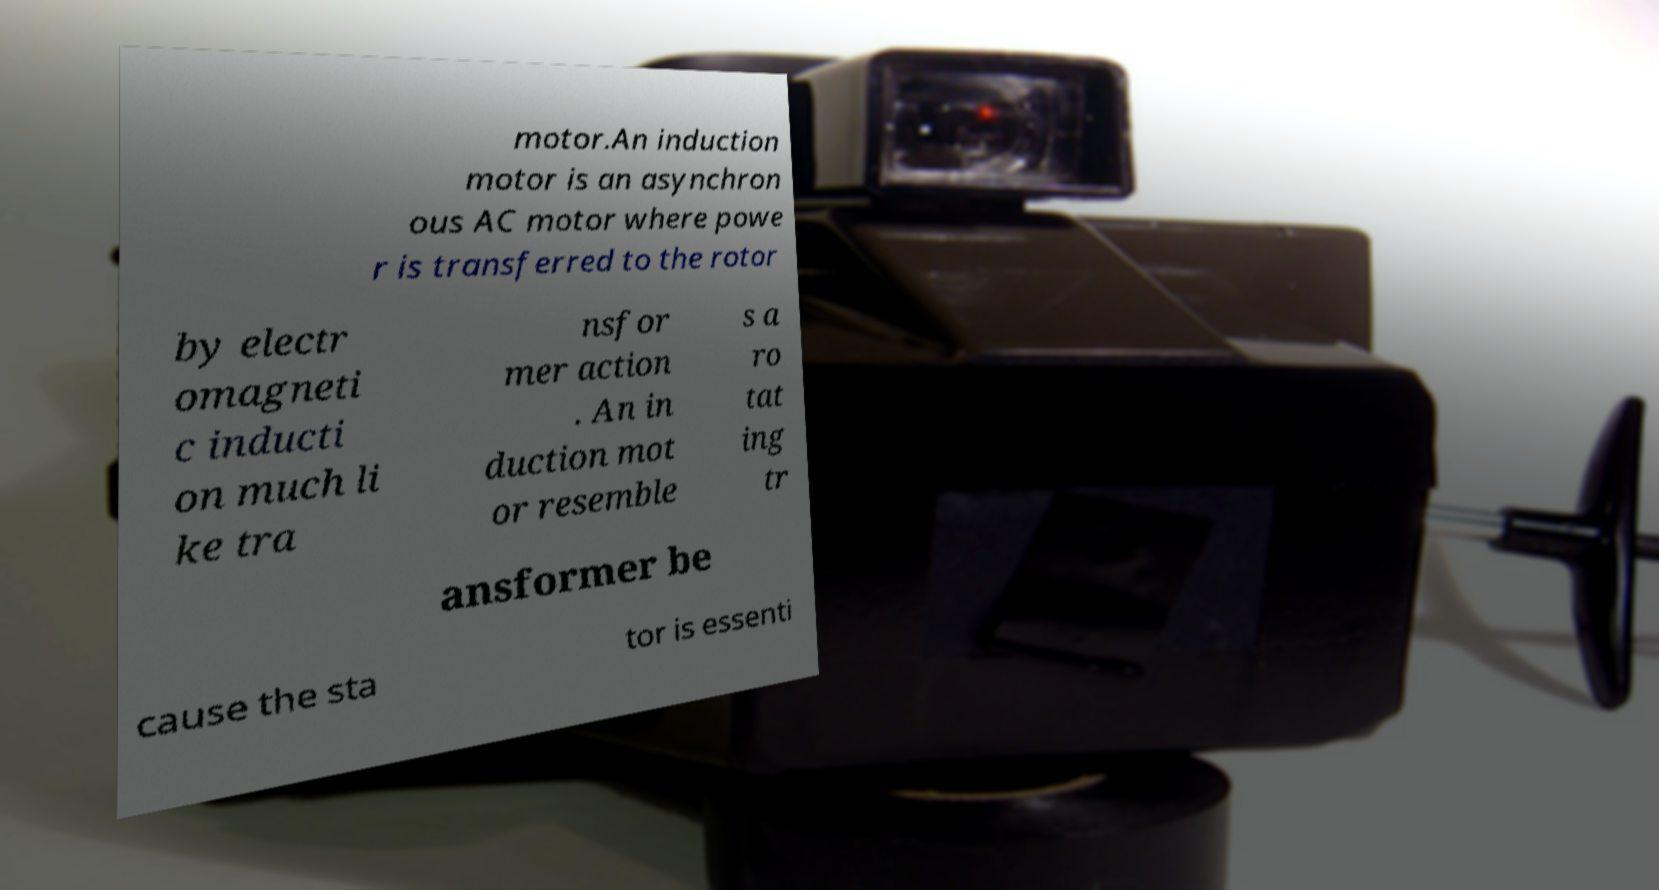I need the written content from this picture converted into text. Can you do that? motor.An induction motor is an asynchron ous AC motor where powe r is transferred to the rotor by electr omagneti c inducti on much li ke tra nsfor mer action . An in duction mot or resemble s a ro tat ing tr ansformer be cause the sta tor is essenti 